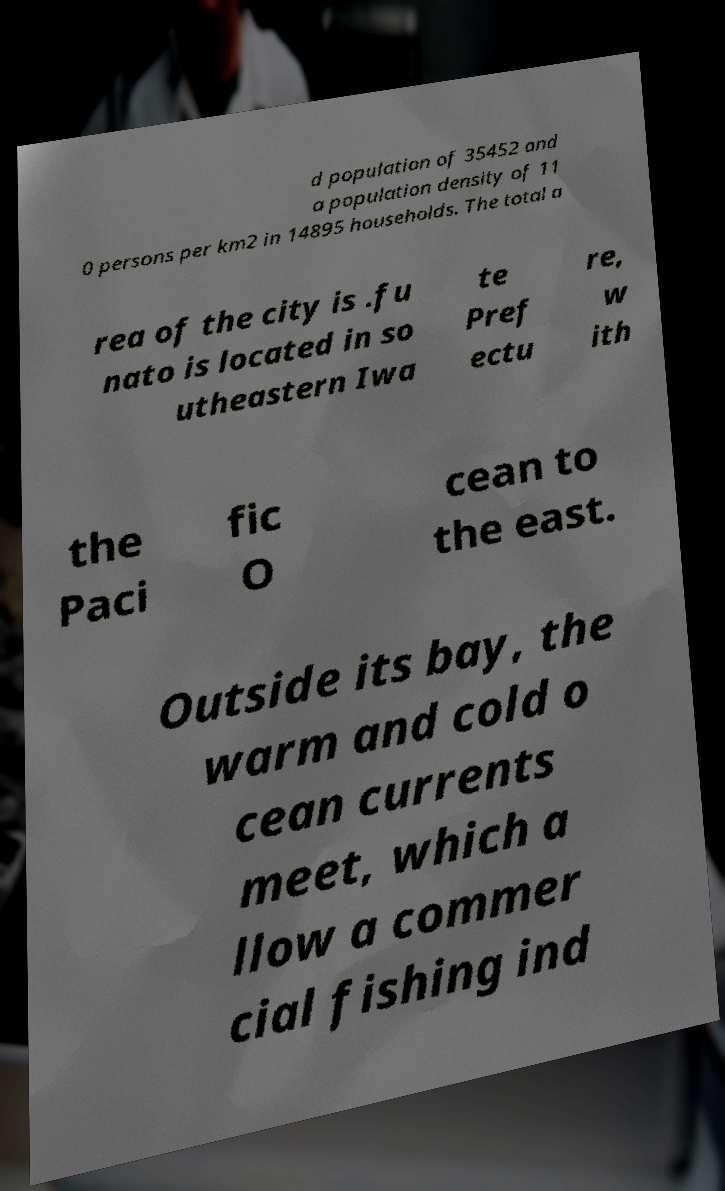Please identify and transcribe the text found in this image. d population of 35452 and a population density of 11 0 persons per km2 in 14895 households. The total a rea of the city is .fu nato is located in so utheastern Iwa te Pref ectu re, w ith the Paci fic O cean to the east. Outside its bay, the warm and cold o cean currents meet, which a llow a commer cial fishing ind 